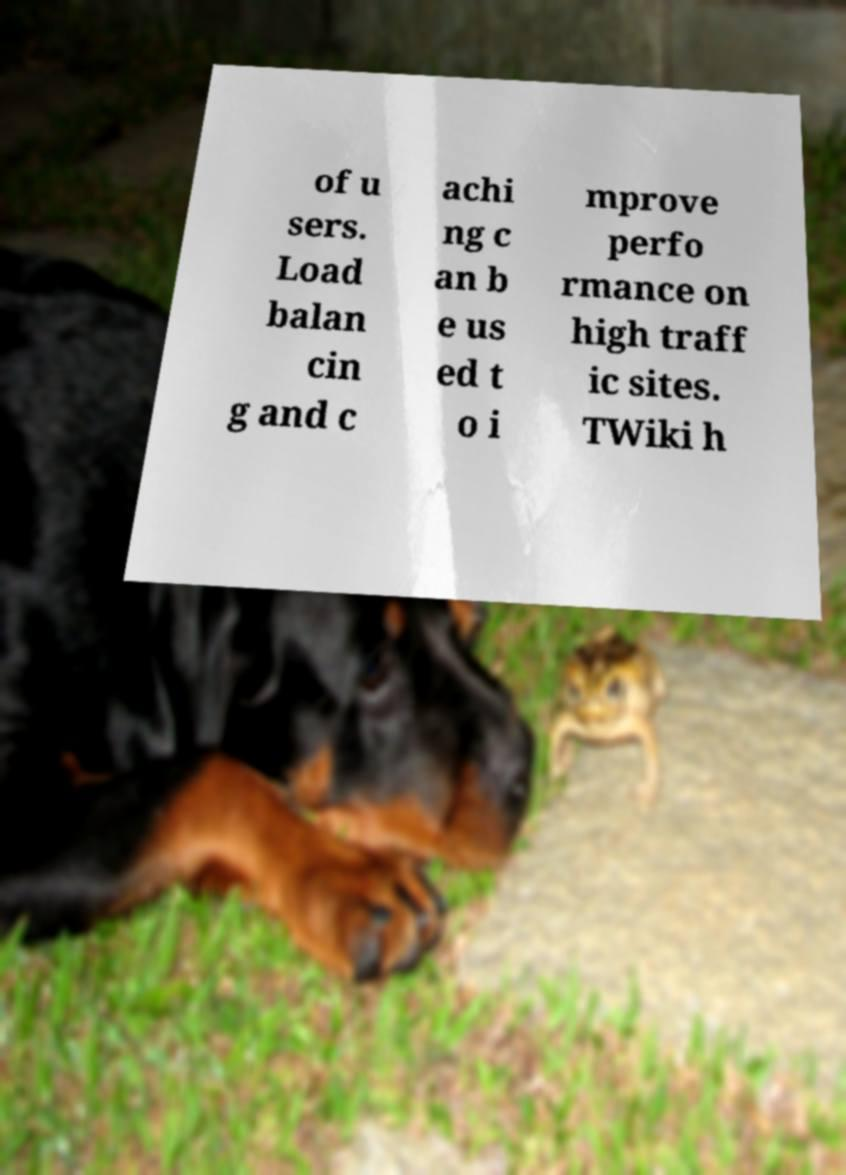For documentation purposes, I need the text within this image transcribed. Could you provide that? of u sers. Load balan cin g and c achi ng c an b e us ed t o i mprove perfo rmance on high traff ic sites. TWiki h 